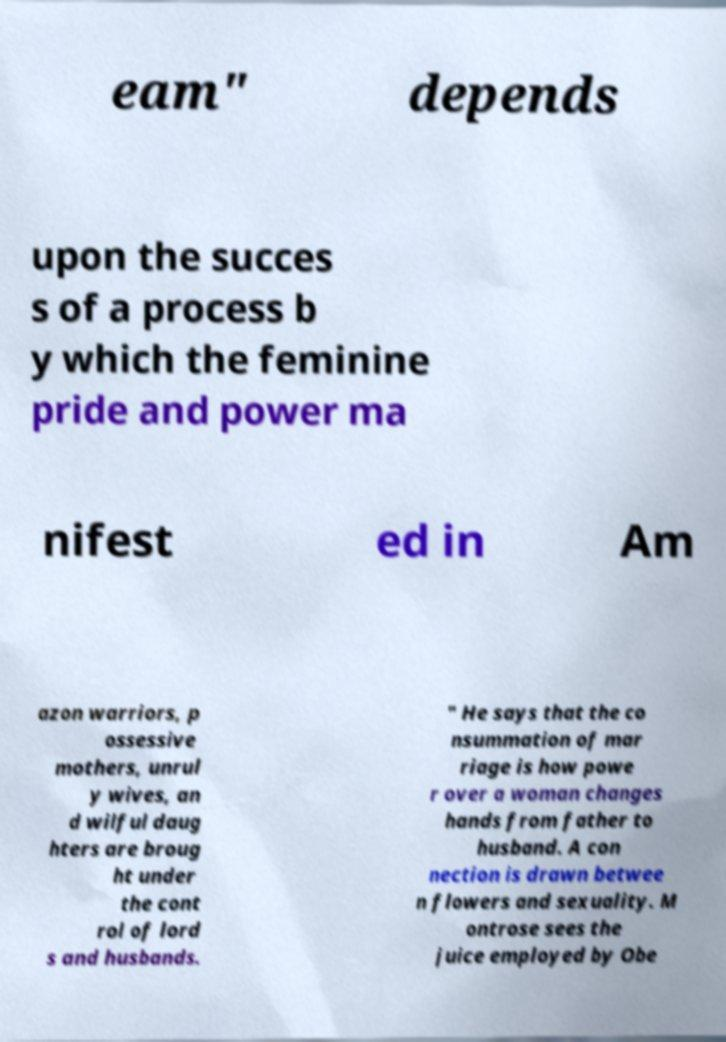Could you extract and type out the text from this image? eam" depends upon the succes s of a process b y which the feminine pride and power ma nifest ed in Am azon warriors, p ossessive mothers, unrul y wives, an d wilful daug hters are broug ht under the cont rol of lord s and husbands. " He says that the co nsummation of mar riage is how powe r over a woman changes hands from father to husband. A con nection is drawn betwee n flowers and sexuality. M ontrose sees the juice employed by Obe 